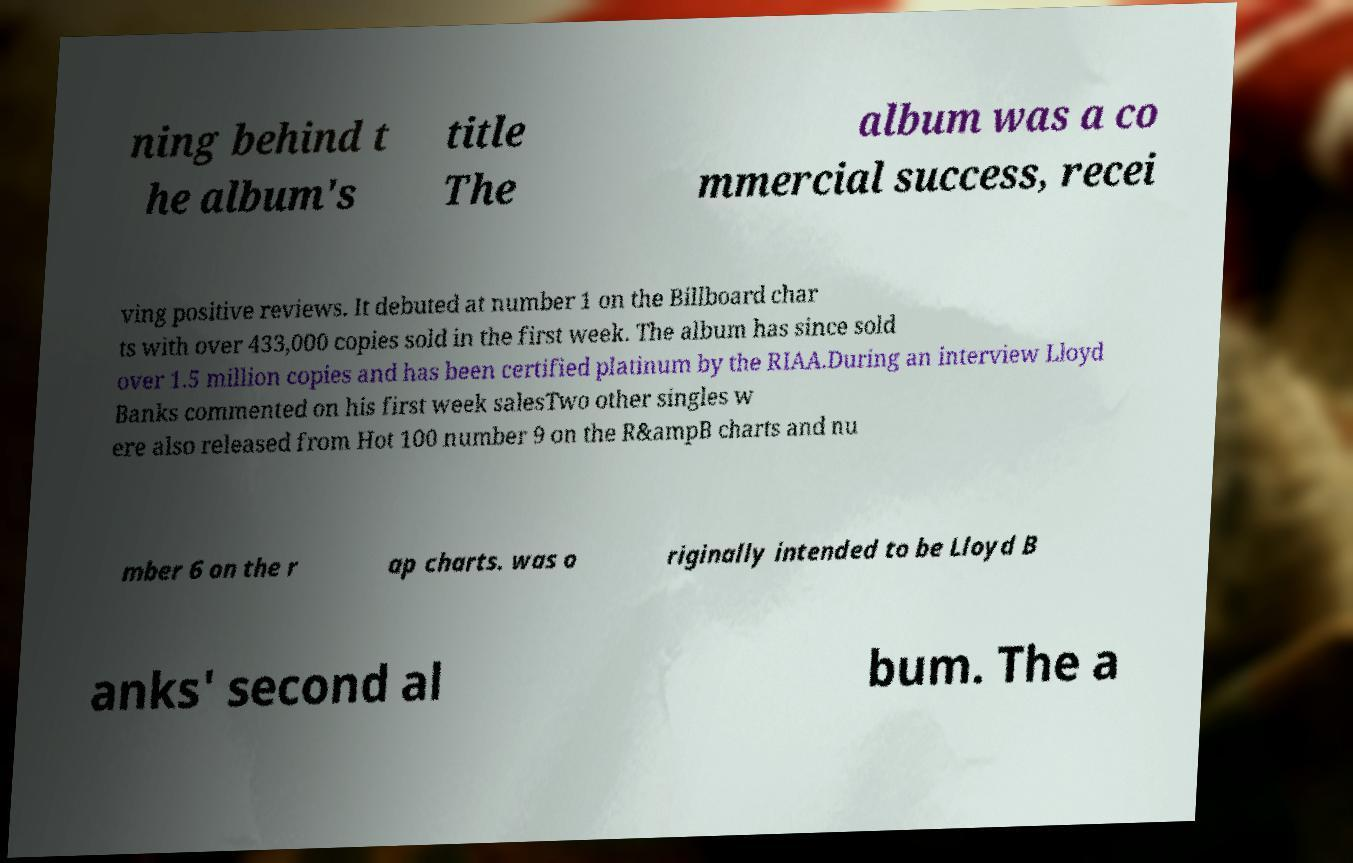Please identify and transcribe the text found in this image. ning behind t he album's title The album was a co mmercial success, recei ving positive reviews. It debuted at number 1 on the Billboard char ts with over 433,000 copies sold in the first week. The album has since sold over 1.5 million copies and has been certified platinum by the RIAA.During an interview Lloyd Banks commented on his first week salesTwo other singles w ere also released from Hot 100 number 9 on the R&ampB charts and nu mber 6 on the r ap charts. was o riginally intended to be Lloyd B anks' second al bum. The a 